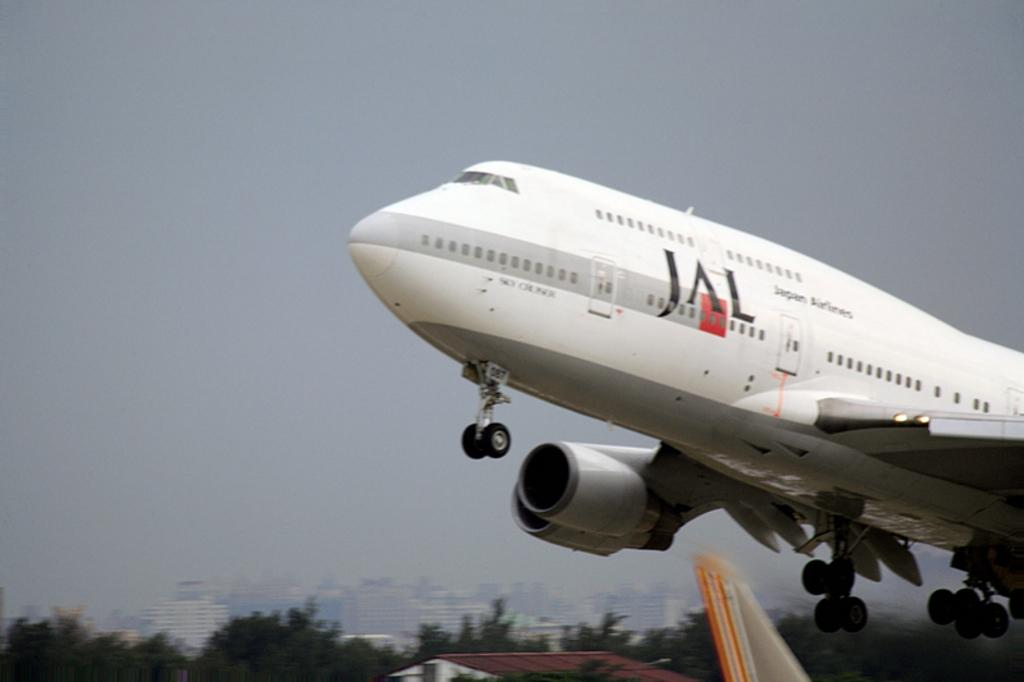What is the main subject of the image? The main subject of the image is a flight. What structures can be seen in the image? There are buildings in the image. What type of natural vegetation is visible in the image? There are trees in the image. What is visible in the background of the image? The sky is visible in the image. What type of roof can be seen on the flight in the image? There is no roof present on the flight in the image, as it is an airplane. What type of mist can be seen surrounding the buildings in the image? There is no mist present in the image; the buildings and their surroundings are clearly visible. 